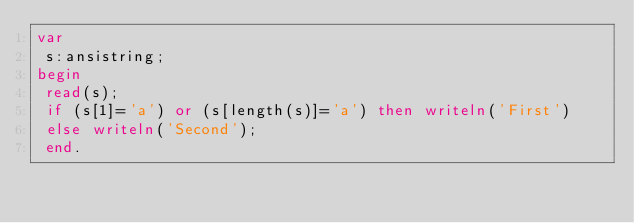<code> <loc_0><loc_0><loc_500><loc_500><_Pascal_>var
 s:ansistring;
begin
 read(s);
 if (s[1]='a') or (s[length(s)]='a') then writeln('First')
 else writeln('Second');
 end.</code> 